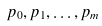Convert formula to latex. <formula><loc_0><loc_0><loc_500><loc_500>p _ { 0 } , p _ { 1 } , \dots , p _ { m }</formula> 